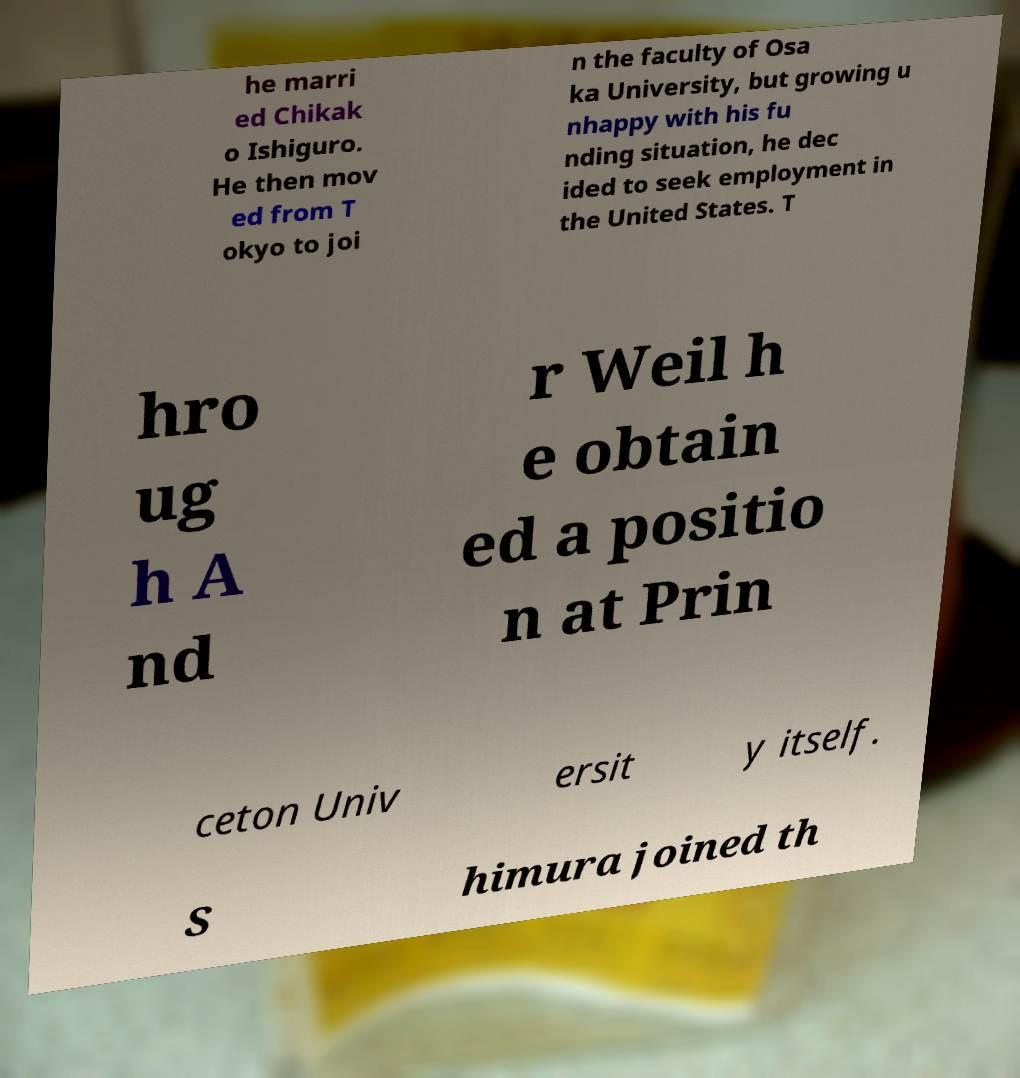Can you read and provide the text displayed in the image?This photo seems to have some interesting text. Can you extract and type it out for me? he marri ed Chikak o Ishiguro. He then mov ed from T okyo to joi n the faculty of Osa ka University, but growing u nhappy with his fu nding situation, he dec ided to seek employment in the United States. T hro ug h A nd r Weil h e obtain ed a positio n at Prin ceton Univ ersit y itself. S himura joined th 